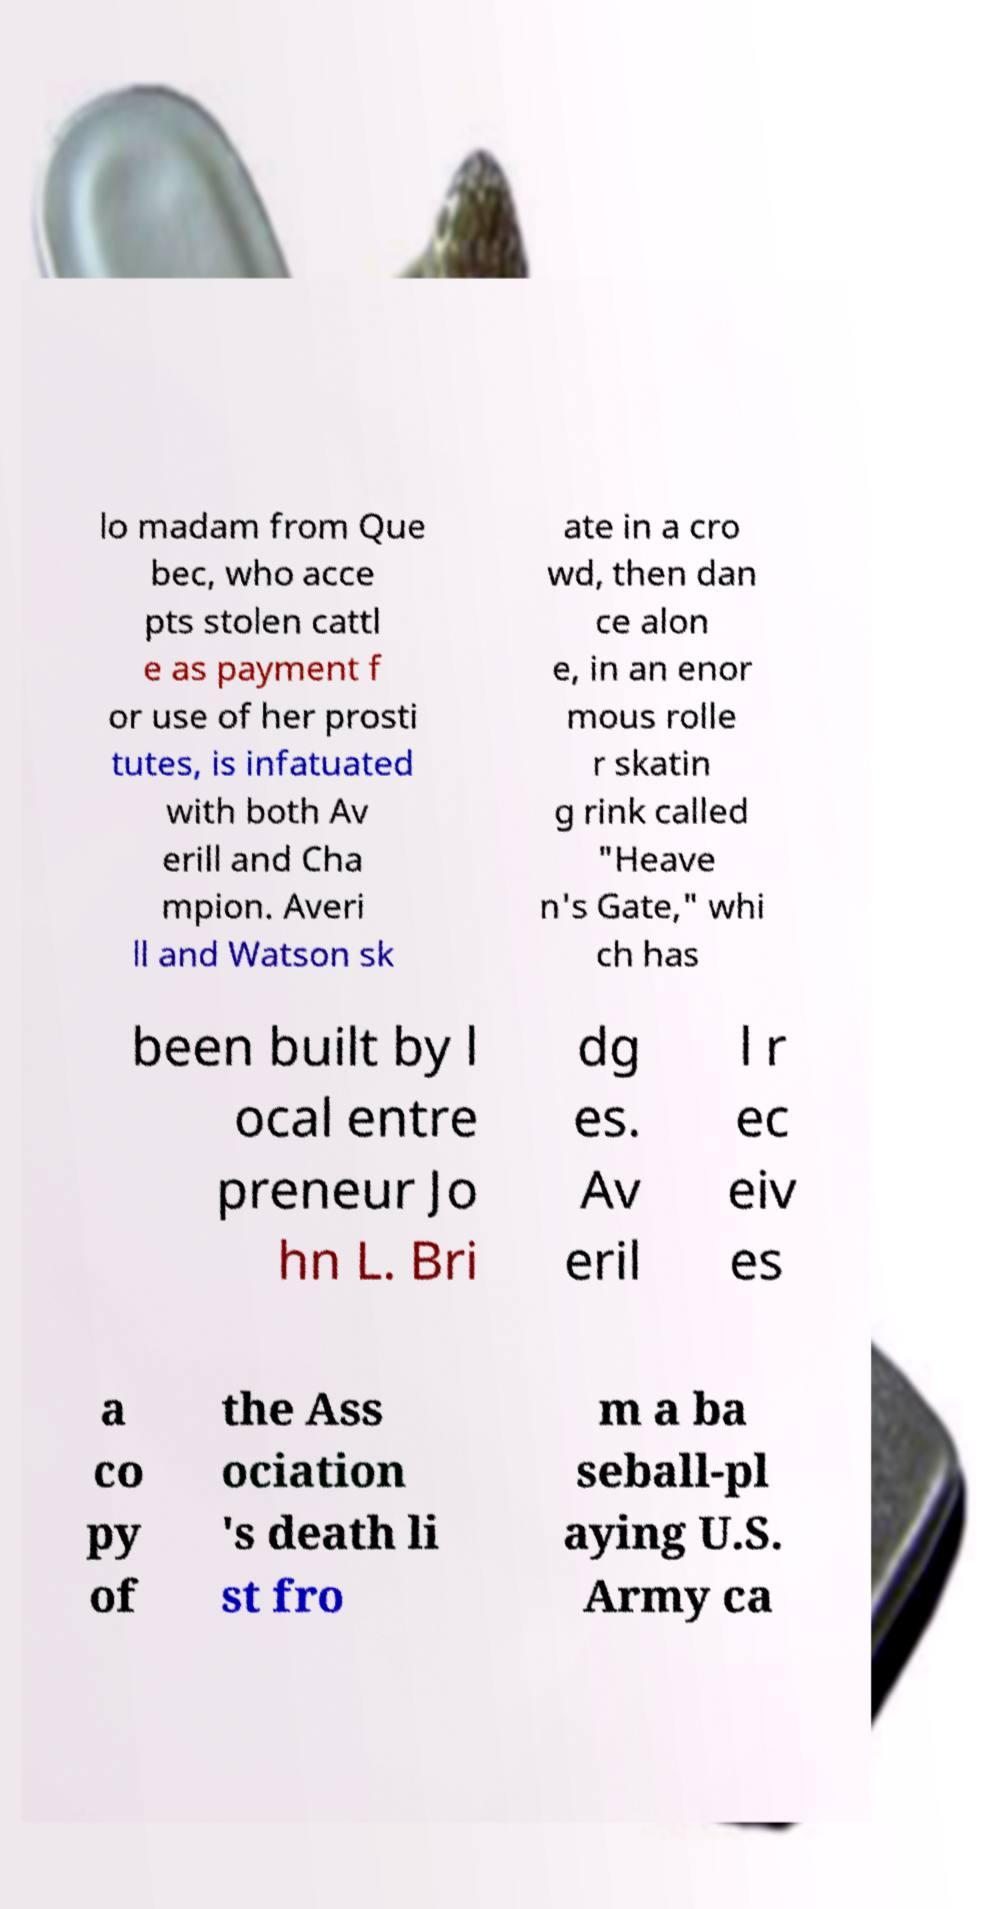Can you read and provide the text displayed in the image?This photo seems to have some interesting text. Can you extract and type it out for me? lo madam from Que bec, who acce pts stolen cattl e as payment f or use of her prosti tutes, is infatuated with both Av erill and Cha mpion. Averi ll and Watson sk ate in a cro wd, then dan ce alon e, in an enor mous rolle r skatin g rink called "Heave n's Gate," whi ch has been built by l ocal entre preneur Jo hn L. Bri dg es. Av eril l r ec eiv es a co py of the Ass ociation 's death li st fro m a ba seball-pl aying U.S. Army ca 